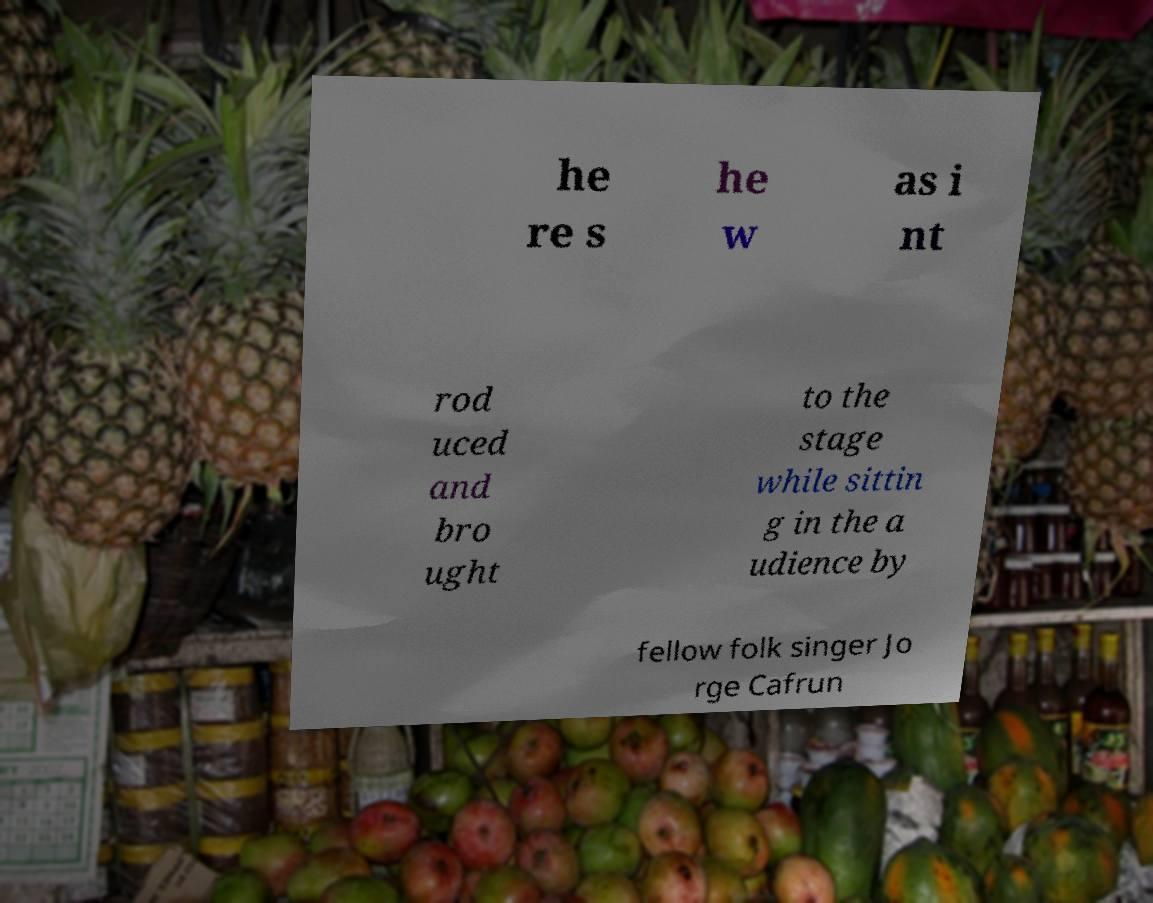There's text embedded in this image that I need extracted. Can you transcribe it verbatim? he re s he w as i nt rod uced and bro ught to the stage while sittin g in the a udience by fellow folk singer Jo rge Cafrun 